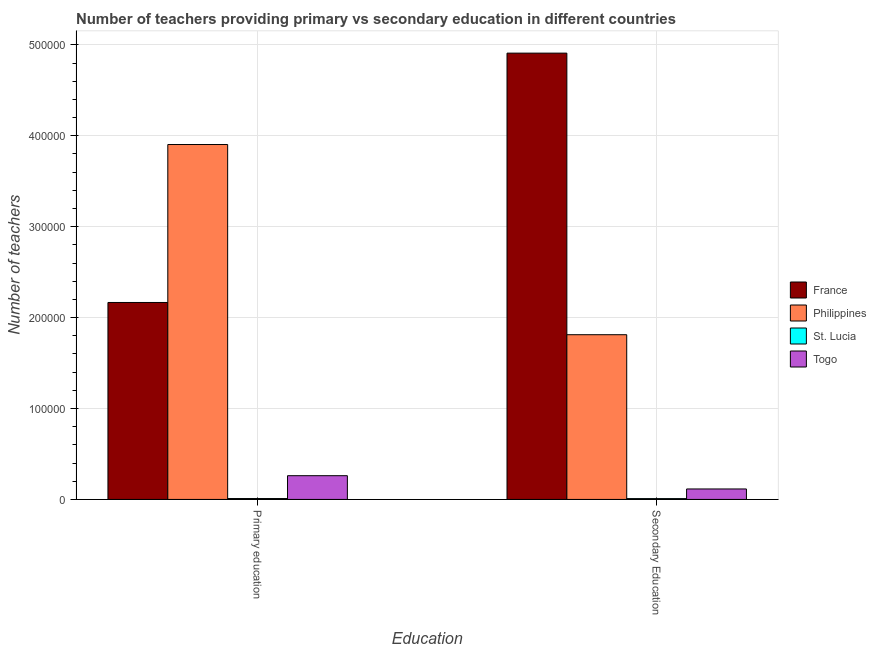Are the number of bars per tick equal to the number of legend labels?
Your answer should be very brief. Yes. How many bars are there on the 1st tick from the right?
Offer a terse response. 4. What is the label of the 2nd group of bars from the left?
Keep it short and to the point. Secondary Education. What is the number of secondary teachers in France?
Keep it short and to the point. 4.91e+05. Across all countries, what is the maximum number of secondary teachers?
Provide a succinct answer. 4.91e+05. Across all countries, what is the minimum number of secondary teachers?
Ensure brevity in your answer.  907. In which country was the number of primary teachers minimum?
Your answer should be very brief. St. Lucia. What is the total number of primary teachers in the graph?
Ensure brevity in your answer.  6.34e+05. What is the difference between the number of primary teachers in France and that in Philippines?
Your response must be concise. -1.74e+05. What is the difference between the number of secondary teachers in Togo and the number of primary teachers in France?
Offer a very short reply. -2.05e+05. What is the average number of secondary teachers per country?
Ensure brevity in your answer.  1.71e+05. What is the difference between the number of primary teachers and number of secondary teachers in St. Lucia?
Make the answer very short. 62. In how many countries, is the number of primary teachers greater than 140000 ?
Provide a short and direct response. 2. What is the ratio of the number of primary teachers in St. Lucia to that in Togo?
Keep it short and to the point. 0.04. In how many countries, is the number of primary teachers greater than the average number of primary teachers taken over all countries?
Provide a short and direct response. 2. What does the 2nd bar from the right in Secondary Education represents?
Provide a short and direct response. St. Lucia. Are all the bars in the graph horizontal?
Provide a succinct answer. No. How many countries are there in the graph?
Provide a succinct answer. 4. Are the values on the major ticks of Y-axis written in scientific E-notation?
Your answer should be compact. No. Does the graph contain any zero values?
Your answer should be very brief. No. Does the graph contain grids?
Your answer should be very brief. Yes. How many legend labels are there?
Offer a very short reply. 4. How are the legend labels stacked?
Your answer should be very brief. Vertical. What is the title of the graph?
Ensure brevity in your answer.  Number of teachers providing primary vs secondary education in different countries. What is the label or title of the X-axis?
Your response must be concise. Education. What is the label or title of the Y-axis?
Ensure brevity in your answer.  Number of teachers. What is the Number of teachers in France in Primary education?
Your answer should be compact. 2.17e+05. What is the Number of teachers in Philippines in Primary education?
Offer a terse response. 3.90e+05. What is the Number of teachers of St. Lucia in Primary education?
Provide a succinct answer. 969. What is the Number of teachers in Togo in Primary education?
Offer a terse response. 2.61e+04. What is the Number of teachers of France in Secondary Education?
Provide a short and direct response. 4.91e+05. What is the Number of teachers of Philippines in Secondary Education?
Keep it short and to the point. 1.81e+05. What is the Number of teachers of St. Lucia in Secondary Education?
Give a very brief answer. 907. What is the Number of teachers in Togo in Secondary Education?
Provide a short and direct response. 1.15e+04. Across all Education, what is the maximum Number of teachers in France?
Keep it short and to the point. 4.91e+05. Across all Education, what is the maximum Number of teachers in Philippines?
Make the answer very short. 3.90e+05. Across all Education, what is the maximum Number of teachers in St. Lucia?
Give a very brief answer. 969. Across all Education, what is the maximum Number of teachers of Togo?
Provide a short and direct response. 2.61e+04. Across all Education, what is the minimum Number of teachers in France?
Provide a short and direct response. 2.17e+05. Across all Education, what is the minimum Number of teachers of Philippines?
Your answer should be compact. 1.81e+05. Across all Education, what is the minimum Number of teachers in St. Lucia?
Your answer should be very brief. 907. Across all Education, what is the minimum Number of teachers of Togo?
Make the answer very short. 1.15e+04. What is the total Number of teachers in France in the graph?
Keep it short and to the point. 7.08e+05. What is the total Number of teachers in Philippines in the graph?
Your response must be concise. 5.72e+05. What is the total Number of teachers of St. Lucia in the graph?
Provide a short and direct response. 1876. What is the total Number of teachers in Togo in the graph?
Give a very brief answer. 3.76e+04. What is the difference between the Number of teachers in France in Primary education and that in Secondary Education?
Offer a terse response. -2.74e+05. What is the difference between the Number of teachers in Philippines in Primary education and that in Secondary Education?
Ensure brevity in your answer.  2.09e+05. What is the difference between the Number of teachers of Togo in Primary education and that in Secondary Education?
Your answer should be compact. 1.46e+04. What is the difference between the Number of teachers of France in Primary education and the Number of teachers of Philippines in Secondary Education?
Keep it short and to the point. 3.55e+04. What is the difference between the Number of teachers in France in Primary education and the Number of teachers in St. Lucia in Secondary Education?
Offer a very short reply. 2.16e+05. What is the difference between the Number of teachers of France in Primary education and the Number of teachers of Togo in Secondary Education?
Offer a very short reply. 2.05e+05. What is the difference between the Number of teachers of Philippines in Primary education and the Number of teachers of St. Lucia in Secondary Education?
Your answer should be very brief. 3.90e+05. What is the difference between the Number of teachers of Philippines in Primary education and the Number of teachers of Togo in Secondary Education?
Provide a short and direct response. 3.79e+05. What is the difference between the Number of teachers of St. Lucia in Primary education and the Number of teachers of Togo in Secondary Education?
Your response must be concise. -1.05e+04. What is the average Number of teachers of France per Education?
Offer a very short reply. 3.54e+05. What is the average Number of teachers of Philippines per Education?
Your answer should be compact. 2.86e+05. What is the average Number of teachers in St. Lucia per Education?
Offer a very short reply. 938. What is the average Number of teachers in Togo per Education?
Make the answer very short. 1.88e+04. What is the difference between the Number of teachers of France and Number of teachers of Philippines in Primary education?
Provide a succinct answer. -1.74e+05. What is the difference between the Number of teachers of France and Number of teachers of St. Lucia in Primary education?
Your answer should be very brief. 2.16e+05. What is the difference between the Number of teachers of France and Number of teachers of Togo in Primary education?
Offer a very short reply. 1.91e+05. What is the difference between the Number of teachers of Philippines and Number of teachers of St. Lucia in Primary education?
Keep it short and to the point. 3.89e+05. What is the difference between the Number of teachers of Philippines and Number of teachers of Togo in Primary education?
Your answer should be very brief. 3.64e+05. What is the difference between the Number of teachers in St. Lucia and Number of teachers in Togo in Primary education?
Your response must be concise. -2.51e+04. What is the difference between the Number of teachers of France and Number of teachers of Philippines in Secondary Education?
Your answer should be very brief. 3.10e+05. What is the difference between the Number of teachers of France and Number of teachers of St. Lucia in Secondary Education?
Offer a very short reply. 4.90e+05. What is the difference between the Number of teachers in France and Number of teachers in Togo in Secondary Education?
Provide a succinct answer. 4.79e+05. What is the difference between the Number of teachers of Philippines and Number of teachers of St. Lucia in Secondary Education?
Make the answer very short. 1.80e+05. What is the difference between the Number of teachers of Philippines and Number of teachers of Togo in Secondary Education?
Offer a very short reply. 1.70e+05. What is the difference between the Number of teachers in St. Lucia and Number of teachers in Togo in Secondary Education?
Give a very brief answer. -1.06e+04. What is the ratio of the Number of teachers of France in Primary education to that in Secondary Education?
Your response must be concise. 0.44. What is the ratio of the Number of teachers of Philippines in Primary education to that in Secondary Education?
Provide a succinct answer. 2.15. What is the ratio of the Number of teachers in St. Lucia in Primary education to that in Secondary Education?
Make the answer very short. 1.07. What is the ratio of the Number of teachers of Togo in Primary education to that in Secondary Education?
Provide a short and direct response. 2.27. What is the difference between the highest and the second highest Number of teachers in France?
Your answer should be very brief. 2.74e+05. What is the difference between the highest and the second highest Number of teachers in Philippines?
Keep it short and to the point. 2.09e+05. What is the difference between the highest and the second highest Number of teachers in Togo?
Give a very brief answer. 1.46e+04. What is the difference between the highest and the lowest Number of teachers of France?
Offer a terse response. 2.74e+05. What is the difference between the highest and the lowest Number of teachers in Philippines?
Make the answer very short. 2.09e+05. What is the difference between the highest and the lowest Number of teachers in St. Lucia?
Ensure brevity in your answer.  62. What is the difference between the highest and the lowest Number of teachers of Togo?
Provide a succinct answer. 1.46e+04. 